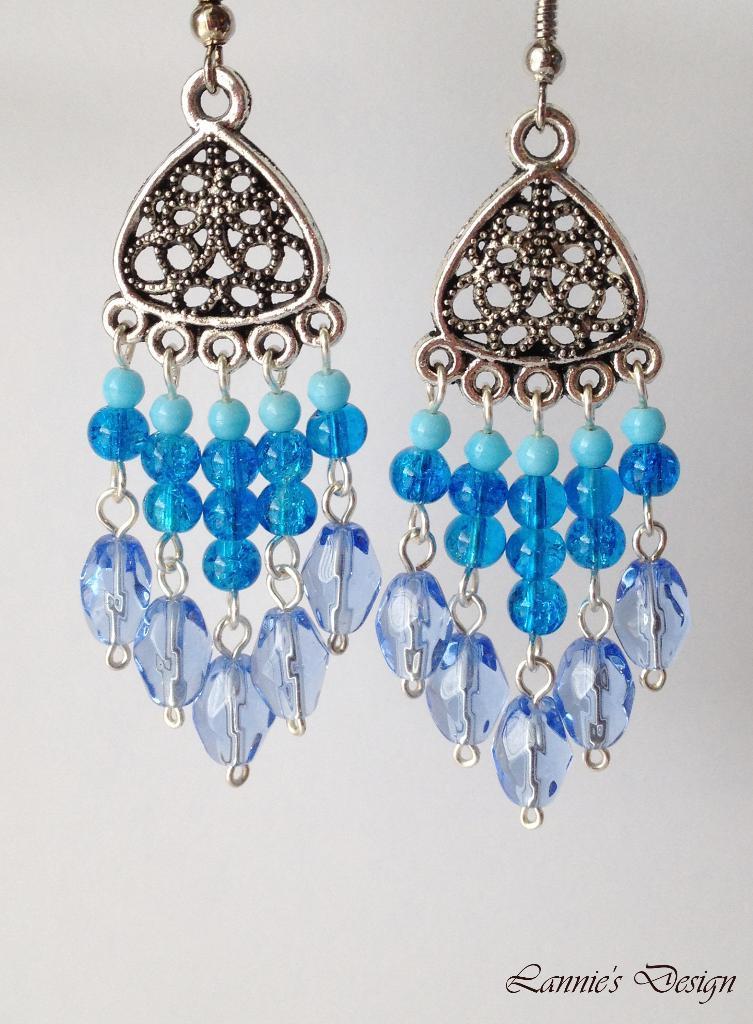How would you summarize this image in a sentence or two? In this image the background is gray in color and in the middle of the image there is a pair of earrings. 